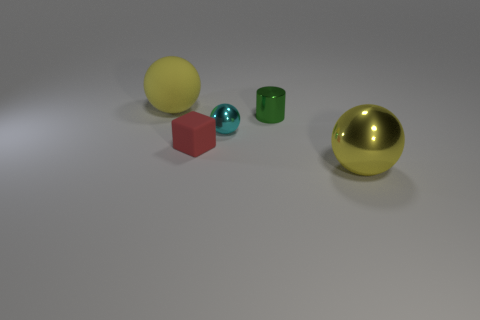Subtract all spheres. How many objects are left? 2 Add 1 purple shiny things. How many objects exist? 6 Add 2 big yellow objects. How many big yellow objects exist? 4 Subtract 0 blue spheres. How many objects are left? 5 Subtract all red matte things. Subtract all tiny green shiny cylinders. How many objects are left? 3 Add 3 big yellow objects. How many big yellow objects are left? 5 